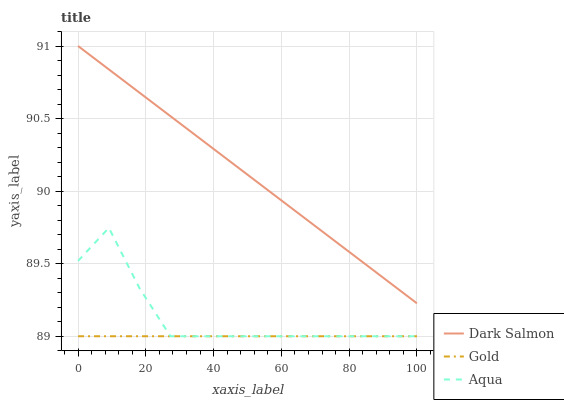Does Dark Salmon have the minimum area under the curve?
Answer yes or no. No. Does Gold have the maximum area under the curve?
Answer yes or no. No. Is Dark Salmon the smoothest?
Answer yes or no. No. Is Dark Salmon the roughest?
Answer yes or no. No. Does Dark Salmon have the lowest value?
Answer yes or no. No. Does Gold have the highest value?
Answer yes or no. No. Is Aqua less than Dark Salmon?
Answer yes or no. Yes. Is Dark Salmon greater than Gold?
Answer yes or no. Yes. Does Aqua intersect Dark Salmon?
Answer yes or no. No. 